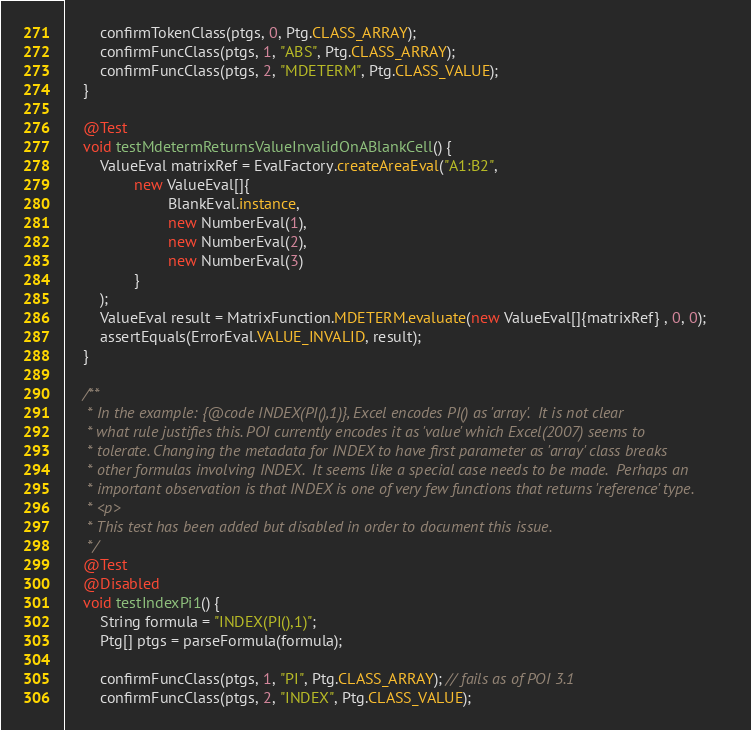Convert code to text. <code><loc_0><loc_0><loc_500><loc_500><_Java_>
        confirmTokenClass(ptgs, 0, Ptg.CLASS_ARRAY);
        confirmFuncClass(ptgs, 1, "ABS", Ptg.CLASS_ARRAY);
        confirmFuncClass(ptgs, 2, "MDETERM", Ptg.CLASS_VALUE);
    }

    @Test
    void testMdetermReturnsValueInvalidOnABlankCell() {
        ValueEval matrixRef = EvalFactory.createAreaEval("A1:B2",
                new ValueEval[]{
                        BlankEval.instance,
                        new NumberEval(1),
                        new NumberEval(2),
                        new NumberEval(3)
                }
        );
        ValueEval result = MatrixFunction.MDETERM.evaluate(new ValueEval[]{matrixRef} , 0, 0);
        assertEquals(ErrorEval.VALUE_INVALID, result);
    }

    /**
     * In the example: {@code INDEX(PI(),1)}, Excel encodes PI() as 'array'.  It is not clear
     * what rule justifies this. POI currently encodes it as 'value' which Excel(2007) seems to
     * tolerate. Changing the metadata for INDEX to have first parameter as 'array' class breaks
     * other formulas involving INDEX.  It seems like a special case needs to be made.  Perhaps an
     * important observation is that INDEX is one of very few functions that returns 'reference' type.
     * <p>
     * This test has been added but disabled in order to document this issue.
     */
    @Test
    @Disabled
    void testIndexPi1() {
        String formula = "INDEX(PI(),1)";
        Ptg[] ptgs = parseFormula(formula);

        confirmFuncClass(ptgs, 1, "PI", Ptg.CLASS_ARRAY); // fails as of POI 3.1
        confirmFuncClass(ptgs, 2, "INDEX", Ptg.CLASS_VALUE);</code> 